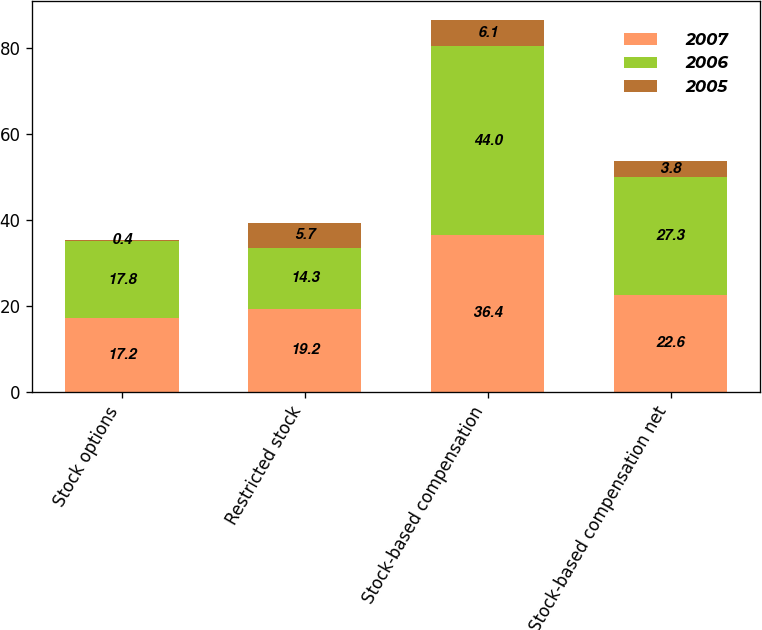<chart> <loc_0><loc_0><loc_500><loc_500><stacked_bar_chart><ecel><fcel>Stock options<fcel>Restricted stock<fcel>Stock-based compensation<fcel>Stock-based compensation net<nl><fcel>2007<fcel>17.2<fcel>19.2<fcel>36.4<fcel>22.6<nl><fcel>2006<fcel>17.8<fcel>14.3<fcel>44<fcel>27.3<nl><fcel>2005<fcel>0.4<fcel>5.7<fcel>6.1<fcel>3.8<nl></chart> 